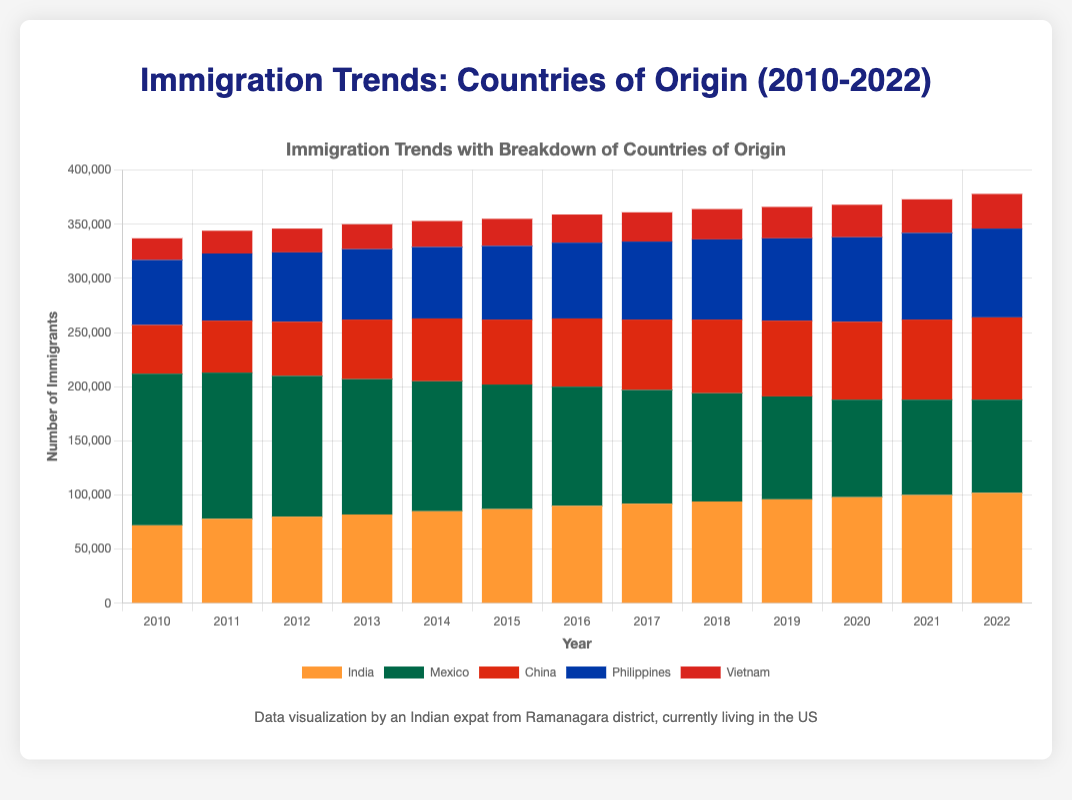Which country had the highest number of immigrants in 2010? By looking at the stack for the year 2010, the segment representing Mexico is the tallest, indicating it had the highest number of immigrants.
Answer: Mexico How did the number of immigrants from India compare to those from China in 2015? The height of the Indian segment in 2015 is higher than that of the Chinese segment. Specifically, India had 87,000 immigrants while China had 60,000.
Answer: India had more immigrants than China What was the combined number of immigrants from the Philippines and Vietnam in 2018? In 2018, the Philippines had 74,000 immigrants and Vietnam had 28,000. Adding these numbers, we get 74,000 + 28,000 = 102,000.
Answer: 102,000 Which year saw the smallest differential in the number of immigrants from Mexico and China? By examining the widths of the segments for Mexico and China across the years, we see that the smallest difference is in 2019, where Mexico had 95,000 and China had 70,000. The difference is 95,000 - 70,000 = 25,000.
Answer: 2019 From 2010 to 2022, how did the number of immigrants from Mexico change? In 2010, Mexico had 140,000 immigrants. By 2022, this number decreased to 86,000. The change is 86,000 - 140,000 = -54,000. Therefore, the number decreased by 54,000.
Answer: Decreased by 54,000 Which country saw the most consistent increase in the number of immigrants from 2010 to 2022? By observing the trends, India shows a consistent increase in the number of immigrants every year without any drops.
Answer: India In which year was the total number of immigrants the highest? By visually inspecting the total height of the bars for each year, 2010 had the highest total number of immigrants.
Answer: 2010 What was the average number of immigrants from China over the 13 years? Summing the immigration numbers for China over the 13 years and then dividing by 13: \((45000+48000+50000+55000+58000+60000+63000+65000+68000+70000+72000+74000+76000)/13 = 59,538.46\)
Answer: 59,538.46 By how much did the number of immigrants from Vietnam increase from 2010 to 2022? In 2010, Vietnam had 20,000 immigrants and by 2022, this number increased to 32,000. The increase is 32,000 - 20,000 = 12,000.
Answer: 12,000 